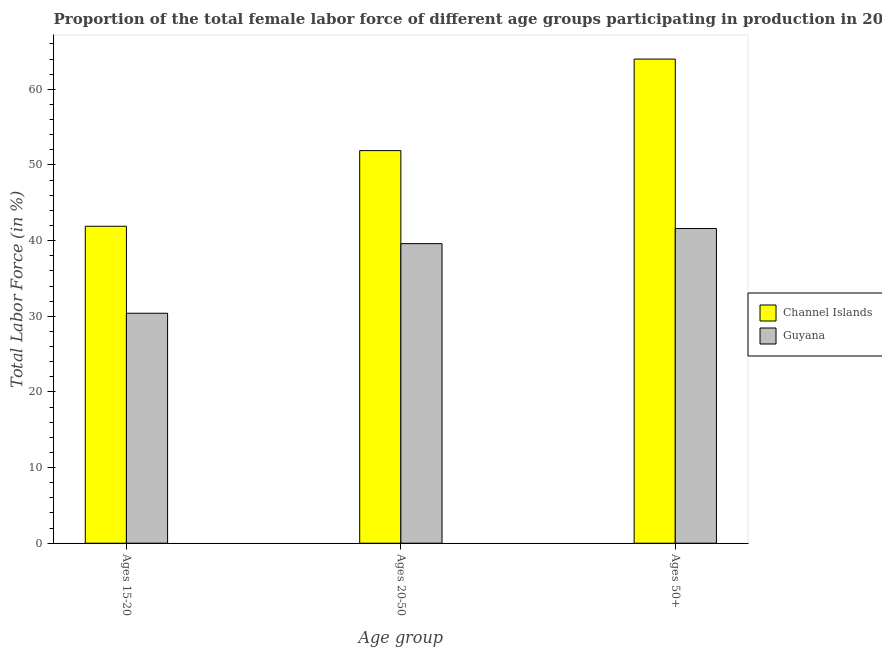How many different coloured bars are there?
Ensure brevity in your answer.  2. Are the number of bars per tick equal to the number of legend labels?
Your answer should be compact. Yes. Are the number of bars on each tick of the X-axis equal?
Offer a terse response. Yes. How many bars are there on the 1st tick from the right?
Make the answer very short. 2. What is the label of the 2nd group of bars from the left?
Give a very brief answer. Ages 20-50. What is the percentage of female labor force within the age group 15-20 in Channel Islands?
Make the answer very short. 41.9. Across all countries, what is the maximum percentage of female labor force within the age group 20-50?
Your answer should be very brief. 51.9. Across all countries, what is the minimum percentage of female labor force within the age group 15-20?
Your answer should be very brief. 30.4. In which country was the percentage of female labor force above age 50 maximum?
Your answer should be very brief. Channel Islands. In which country was the percentage of female labor force within the age group 20-50 minimum?
Make the answer very short. Guyana. What is the total percentage of female labor force within the age group 15-20 in the graph?
Your answer should be compact. 72.3. What is the difference between the percentage of female labor force within the age group 20-50 in Channel Islands and that in Guyana?
Keep it short and to the point. 12.3. What is the difference between the percentage of female labor force within the age group 15-20 in Channel Islands and the percentage of female labor force within the age group 20-50 in Guyana?
Keep it short and to the point. 2.3. What is the average percentage of female labor force within the age group 15-20 per country?
Keep it short and to the point. 36.15. What is the difference between the percentage of female labor force within the age group 15-20 and percentage of female labor force within the age group 20-50 in Channel Islands?
Give a very brief answer. -10. What is the ratio of the percentage of female labor force above age 50 in Guyana to that in Channel Islands?
Keep it short and to the point. 0.65. Is the difference between the percentage of female labor force within the age group 20-50 in Guyana and Channel Islands greater than the difference between the percentage of female labor force within the age group 15-20 in Guyana and Channel Islands?
Your answer should be compact. No. What is the difference between the highest and the second highest percentage of female labor force above age 50?
Your answer should be compact. 22.4. What is the difference between the highest and the lowest percentage of female labor force above age 50?
Offer a terse response. 22.4. In how many countries, is the percentage of female labor force within the age group 15-20 greater than the average percentage of female labor force within the age group 15-20 taken over all countries?
Offer a very short reply. 1. Is the sum of the percentage of female labor force above age 50 in Channel Islands and Guyana greater than the maximum percentage of female labor force within the age group 20-50 across all countries?
Make the answer very short. Yes. What does the 2nd bar from the left in Ages 20-50 represents?
Make the answer very short. Guyana. What does the 1st bar from the right in Ages 15-20 represents?
Give a very brief answer. Guyana. Are all the bars in the graph horizontal?
Ensure brevity in your answer.  No. What is the difference between two consecutive major ticks on the Y-axis?
Your answer should be compact. 10. Does the graph contain any zero values?
Ensure brevity in your answer.  No. What is the title of the graph?
Give a very brief answer. Proportion of the total female labor force of different age groups participating in production in 2006. Does "Cuba" appear as one of the legend labels in the graph?
Offer a very short reply. No. What is the label or title of the X-axis?
Give a very brief answer. Age group. What is the label or title of the Y-axis?
Your response must be concise. Total Labor Force (in %). What is the Total Labor Force (in %) of Channel Islands in Ages 15-20?
Offer a terse response. 41.9. What is the Total Labor Force (in %) in Guyana in Ages 15-20?
Offer a very short reply. 30.4. What is the Total Labor Force (in %) in Channel Islands in Ages 20-50?
Ensure brevity in your answer.  51.9. What is the Total Labor Force (in %) in Guyana in Ages 20-50?
Your answer should be compact. 39.6. What is the Total Labor Force (in %) of Channel Islands in Ages 50+?
Your response must be concise. 64. What is the Total Labor Force (in %) in Guyana in Ages 50+?
Make the answer very short. 41.6. Across all Age group, what is the maximum Total Labor Force (in %) in Channel Islands?
Ensure brevity in your answer.  64. Across all Age group, what is the maximum Total Labor Force (in %) in Guyana?
Provide a short and direct response. 41.6. Across all Age group, what is the minimum Total Labor Force (in %) in Channel Islands?
Provide a succinct answer. 41.9. Across all Age group, what is the minimum Total Labor Force (in %) of Guyana?
Your answer should be very brief. 30.4. What is the total Total Labor Force (in %) in Channel Islands in the graph?
Your answer should be compact. 157.8. What is the total Total Labor Force (in %) of Guyana in the graph?
Provide a short and direct response. 111.6. What is the difference between the Total Labor Force (in %) of Channel Islands in Ages 15-20 and that in Ages 50+?
Provide a succinct answer. -22.1. What is the difference between the Total Labor Force (in %) of Guyana in Ages 15-20 and that in Ages 50+?
Keep it short and to the point. -11.2. What is the difference between the Total Labor Force (in %) of Channel Islands in Ages 15-20 and the Total Labor Force (in %) of Guyana in Ages 50+?
Keep it short and to the point. 0.3. What is the average Total Labor Force (in %) in Channel Islands per Age group?
Ensure brevity in your answer.  52.6. What is the average Total Labor Force (in %) of Guyana per Age group?
Give a very brief answer. 37.2. What is the difference between the Total Labor Force (in %) of Channel Islands and Total Labor Force (in %) of Guyana in Ages 20-50?
Your answer should be very brief. 12.3. What is the difference between the Total Labor Force (in %) of Channel Islands and Total Labor Force (in %) of Guyana in Ages 50+?
Offer a very short reply. 22.4. What is the ratio of the Total Labor Force (in %) in Channel Islands in Ages 15-20 to that in Ages 20-50?
Your response must be concise. 0.81. What is the ratio of the Total Labor Force (in %) of Guyana in Ages 15-20 to that in Ages 20-50?
Your response must be concise. 0.77. What is the ratio of the Total Labor Force (in %) in Channel Islands in Ages 15-20 to that in Ages 50+?
Give a very brief answer. 0.65. What is the ratio of the Total Labor Force (in %) in Guyana in Ages 15-20 to that in Ages 50+?
Keep it short and to the point. 0.73. What is the ratio of the Total Labor Force (in %) in Channel Islands in Ages 20-50 to that in Ages 50+?
Offer a very short reply. 0.81. What is the ratio of the Total Labor Force (in %) of Guyana in Ages 20-50 to that in Ages 50+?
Offer a terse response. 0.95. What is the difference between the highest and the lowest Total Labor Force (in %) in Channel Islands?
Offer a terse response. 22.1. 